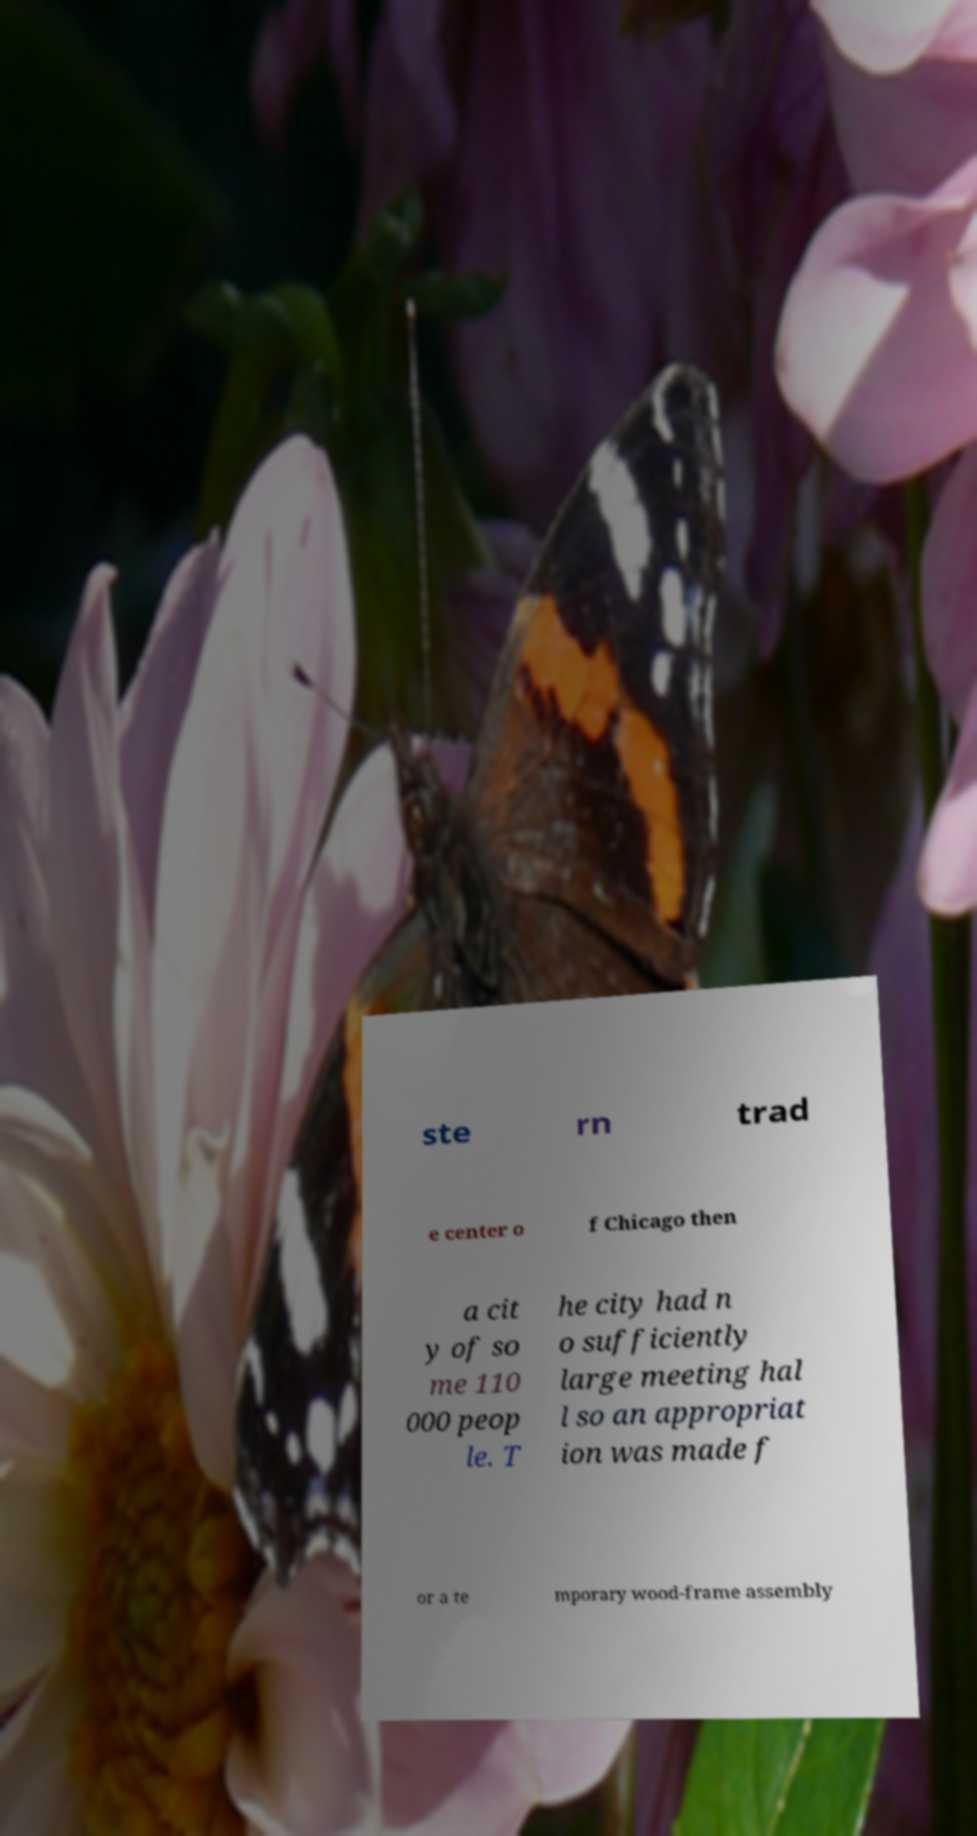What messages or text are displayed in this image? I need them in a readable, typed format. ste rn trad e center o f Chicago then a cit y of so me 110 000 peop le. T he city had n o sufficiently large meeting hal l so an appropriat ion was made f or a te mporary wood-frame assembly 